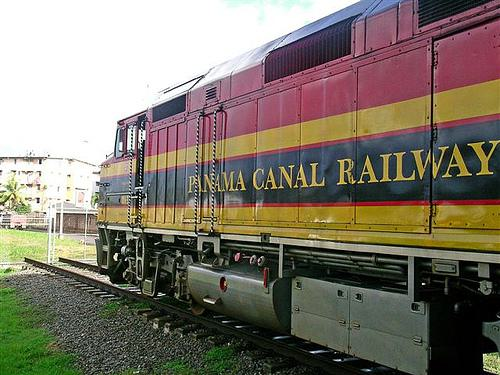Is there a train in the image? Yes, the image features a locomotive from the Panama Canal Railway. It's a vibrant, distinctive train, showcasing the iconic yellow, red, and blue color scheme that symbolizes the historical and cultural significance of this railway, which complements the Panama Canal's operations. 